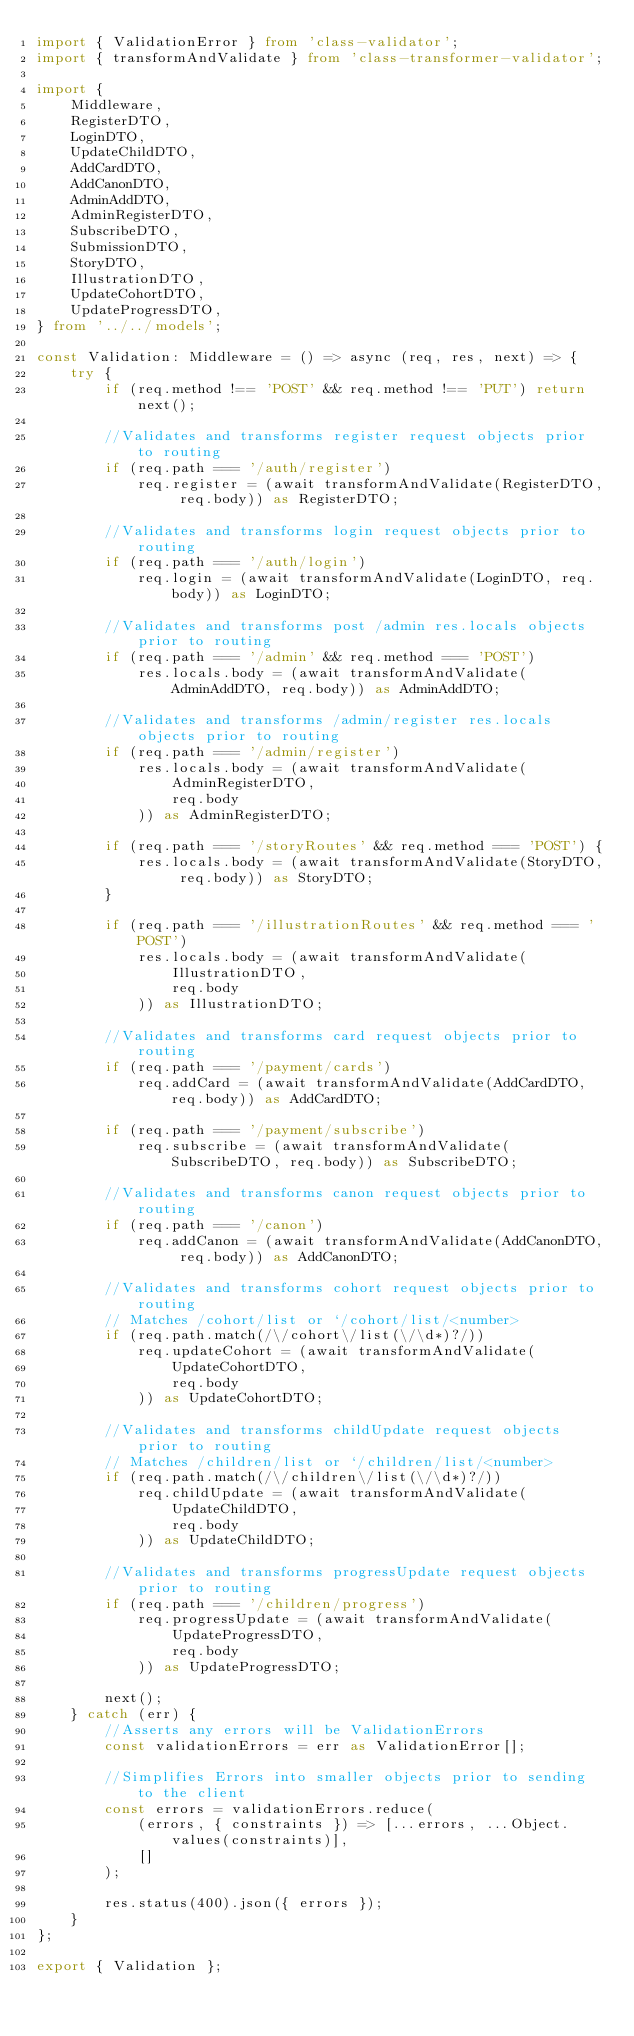Convert code to text. <code><loc_0><loc_0><loc_500><loc_500><_TypeScript_>import { ValidationError } from 'class-validator';
import { transformAndValidate } from 'class-transformer-validator';

import {
    Middleware,
    RegisterDTO,
    LoginDTO,
    UpdateChildDTO,
    AddCardDTO,
    AddCanonDTO,
    AdminAddDTO,
    AdminRegisterDTO,
    SubscribeDTO,
    SubmissionDTO,
    StoryDTO,
    IllustrationDTO,
    UpdateCohortDTO,
    UpdateProgressDTO,
} from '../../models';

const Validation: Middleware = () => async (req, res, next) => {
    try {
        if (req.method !== 'POST' && req.method !== 'PUT') return next();

        //Validates and transforms register request objects prior to routing
        if (req.path === '/auth/register')
            req.register = (await transformAndValidate(RegisterDTO, req.body)) as RegisterDTO;

        //Validates and transforms login request objects prior to routing
        if (req.path === '/auth/login')
            req.login = (await transformAndValidate(LoginDTO, req.body)) as LoginDTO;

        //Validates and transforms post /admin res.locals objects prior to routing
        if (req.path === '/admin' && req.method === 'POST')
            res.locals.body = (await transformAndValidate(AdminAddDTO, req.body)) as AdminAddDTO;

        //Validates and transforms /admin/register res.locals objects prior to routing
        if (req.path === '/admin/register')
            res.locals.body = (await transformAndValidate(
                AdminRegisterDTO,
                req.body
            )) as AdminRegisterDTO;

        if (req.path === '/storyRoutes' && req.method === 'POST') {
            res.locals.body = (await transformAndValidate(StoryDTO, req.body)) as StoryDTO;
        }

        if (req.path === '/illustrationRoutes' && req.method === 'POST')
            res.locals.body = (await transformAndValidate(
                IllustrationDTO,
                req.body
            )) as IllustrationDTO;

        //Validates and transforms card request objects prior to routing
        if (req.path === '/payment/cards')
            req.addCard = (await transformAndValidate(AddCardDTO, req.body)) as AddCardDTO;

        if (req.path === '/payment/subscribe')
            req.subscribe = (await transformAndValidate(SubscribeDTO, req.body)) as SubscribeDTO;

        //Validates and transforms canon request objects prior to routing
        if (req.path === '/canon')
            req.addCanon = (await transformAndValidate(AddCanonDTO, req.body)) as AddCanonDTO;

        //Validates and transforms cohort request objects prior to routing
        // Matches /cohort/list or `/cohort/list/<number>
        if (req.path.match(/\/cohort\/list(\/\d*)?/))
            req.updateCohort = (await transformAndValidate(
                UpdateCohortDTO,
                req.body
            )) as UpdateCohortDTO;

        //Validates and transforms childUpdate request objects prior to routing
        // Matches /children/list or `/children/list/<number>
        if (req.path.match(/\/children\/list(\/\d*)?/))
            req.childUpdate = (await transformAndValidate(
                UpdateChildDTO,
                req.body
            )) as UpdateChildDTO;

        //Validates and transforms progressUpdate request objects prior to routing
        if (req.path === '/children/progress')
            req.progressUpdate = (await transformAndValidate(
                UpdateProgressDTO,
                req.body
            )) as UpdateProgressDTO;

        next();
    } catch (err) {
        //Asserts any errors will be ValidationErrors
        const validationErrors = err as ValidationError[];

        //Simplifies Errors into smaller objects prior to sending to the client
        const errors = validationErrors.reduce(
            (errors, { constraints }) => [...errors, ...Object.values(constraints)],
            []
        );

        res.status(400).json({ errors });
    }
};

export { Validation };
</code> 